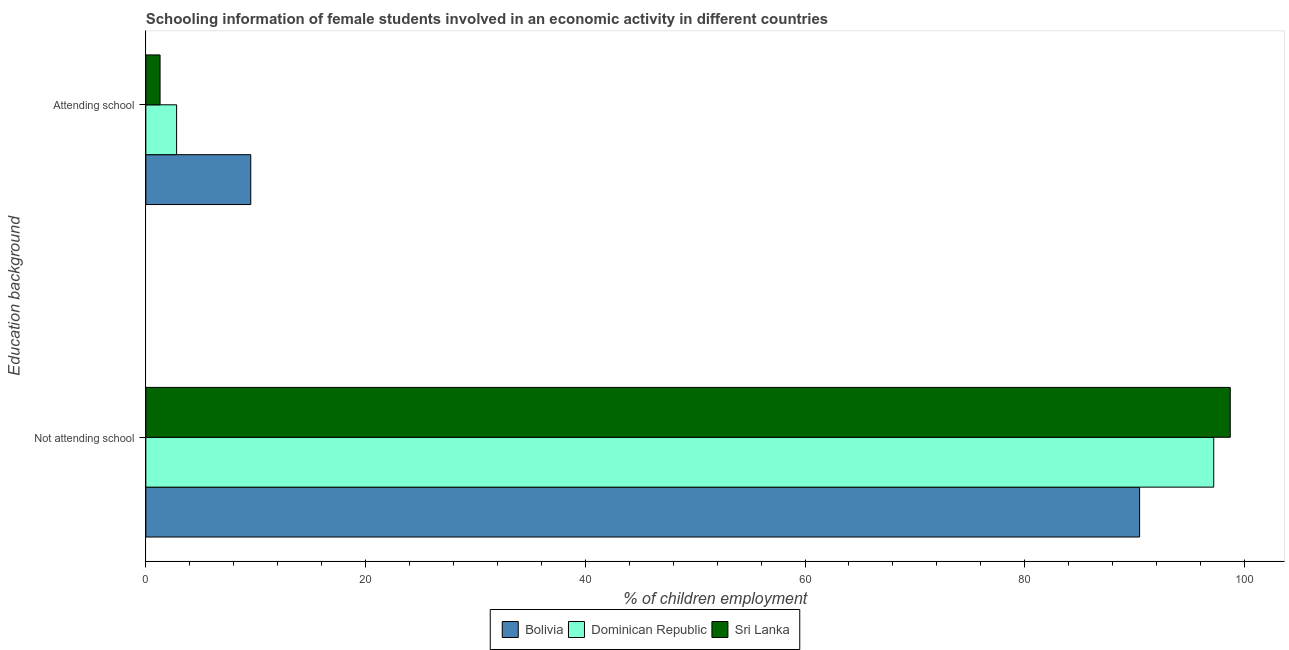Are the number of bars per tick equal to the number of legend labels?
Keep it short and to the point. Yes. Are the number of bars on each tick of the Y-axis equal?
Make the answer very short. Yes. How many bars are there on the 2nd tick from the top?
Provide a short and direct response. 3. What is the label of the 2nd group of bars from the top?
Your answer should be very brief. Not attending school. What is the percentage of employed females who are not attending school in Bolivia?
Offer a very short reply. 90.45. Across all countries, what is the maximum percentage of employed females who are attending school?
Provide a succinct answer. 9.55. Across all countries, what is the minimum percentage of employed females who are not attending school?
Offer a very short reply. 90.45. In which country was the percentage of employed females who are not attending school minimum?
Provide a short and direct response. Bolivia. What is the total percentage of employed females who are attending school in the graph?
Your response must be concise. 13.64. What is the difference between the percentage of employed females who are not attending school in Dominican Republic and that in Bolivia?
Keep it short and to the point. 6.75. What is the difference between the percentage of employed females who are attending school in Dominican Republic and the percentage of employed females who are not attending school in Bolivia?
Your answer should be very brief. -87.65. What is the average percentage of employed females who are attending school per country?
Keep it short and to the point. 4.55. What is the difference between the percentage of employed females who are attending school and percentage of employed females who are not attending school in Sri Lanka?
Make the answer very short. -97.41. What is the ratio of the percentage of employed females who are attending school in Sri Lanka to that in Bolivia?
Offer a very short reply. 0.14. In how many countries, is the percentage of employed females who are not attending school greater than the average percentage of employed females who are not attending school taken over all countries?
Provide a short and direct response. 2. What does the 2nd bar from the top in Not attending school represents?
Provide a short and direct response. Dominican Republic. What does the 2nd bar from the bottom in Not attending school represents?
Your answer should be very brief. Dominican Republic. How many countries are there in the graph?
Make the answer very short. 3. What is the difference between two consecutive major ticks on the X-axis?
Provide a short and direct response. 20. Are the values on the major ticks of X-axis written in scientific E-notation?
Offer a terse response. No. Does the graph contain any zero values?
Offer a very short reply. No. How many legend labels are there?
Offer a terse response. 3. How are the legend labels stacked?
Give a very brief answer. Horizontal. What is the title of the graph?
Offer a very short reply. Schooling information of female students involved in an economic activity in different countries. What is the label or title of the X-axis?
Give a very brief answer. % of children employment. What is the label or title of the Y-axis?
Offer a very short reply. Education background. What is the % of children employment of Bolivia in Not attending school?
Give a very brief answer. 90.45. What is the % of children employment of Dominican Republic in Not attending school?
Ensure brevity in your answer.  97.2. What is the % of children employment in Sri Lanka in Not attending school?
Your answer should be compact. 98.71. What is the % of children employment of Bolivia in Attending school?
Provide a short and direct response. 9.55. What is the % of children employment of Sri Lanka in Attending school?
Provide a succinct answer. 1.29. Across all Education background, what is the maximum % of children employment in Bolivia?
Your answer should be very brief. 90.45. Across all Education background, what is the maximum % of children employment of Dominican Republic?
Your answer should be very brief. 97.2. Across all Education background, what is the maximum % of children employment in Sri Lanka?
Provide a succinct answer. 98.71. Across all Education background, what is the minimum % of children employment in Bolivia?
Your answer should be very brief. 9.55. Across all Education background, what is the minimum % of children employment in Sri Lanka?
Provide a short and direct response. 1.29. What is the total % of children employment of Bolivia in the graph?
Make the answer very short. 100. What is the total % of children employment in Dominican Republic in the graph?
Make the answer very short. 100. What is the total % of children employment in Sri Lanka in the graph?
Offer a terse response. 100. What is the difference between the % of children employment in Bolivia in Not attending school and that in Attending school?
Give a very brief answer. 80.9. What is the difference between the % of children employment in Dominican Republic in Not attending school and that in Attending school?
Make the answer very short. 94.4. What is the difference between the % of children employment in Sri Lanka in Not attending school and that in Attending school?
Offer a very short reply. 97.41. What is the difference between the % of children employment in Bolivia in Not attending school and the % of children employment in Dominican Republic in Attending school?
Provide a succinct answer. 87.65. What is the difference between the % of children employment in Bolivia in Not attending school and the % of children employment in Sri Lanka in Attending school?
Give a very brief answer. 89.16. What is the difference between the % of children employment of Dominican Republic in Not attending school and the % of children employment of Sri Lanka in Attending school?
Offer a terse response. 95.91. What is the average % of children employment in Sri Lanka per Education background?
Offer a very short reply. 50. What is the difference between the % of children employment in Bolivia and % of children employment in Dominican Republic in Not attending school?
Your response must be concise. -6.75. What is the difference between the % of children employment of Bolivia and % of children employment of Sri Lanka in Not attending school?
Offer a terse response. -8.25. What is the difference between the % of children employment of Dominican Republic and % of children employment of Sri Lanka in Not attending school?
Offer a very short reply. -1.5. What is the difference between the % of children employment in Bolivia and % of children employment in Dominican Republic in Attending school?
Your response must be concise. 6.75. What is the difference between the % of children employment in Bolivia and % of children employment in Sri Lanka in Attending school?
Keep it short and to the point. 8.25. What is the difference between the % of children employment of Dominican Republic and % of children employment of Sri Lanka in Attending school?
Your response must be concise. 1.5. What is the ratio of the % of children employment in Bolivia in Not attending school to that in Attending school?
Provide a short and direct response. 9.47. What is the ratio of the % of children employment of Dominican Republic in Not attending school to that in Attending school?
Provide a short and direct response. 34.71. What is the ratio of the % of children employment of Sri Lanka in Not attending school to that in Attending school?
Ensure brevity in your answer.  76.22. What is the difference between the highest and the second highest % of children employment of Bolivia?
Make the answer very short. 80.9. What is the difference between the highest and the second highest % of children employment of Dominican Republic?
Make the answer very short. 94.4. What is the difference between the highest and the second highest % of children employment in Sri Lanka?
Provide a short and direct response. 97.41. What is the difference between the highest and the lowest % of children employment in Bolivia?
Give a very brief answer. 80.9. What is the difference between the highest and the lowest % of children employment of Dominican Republic?
Provide a short and direct response. 94.4. What is the difference between the highest and the lowest % of children employment of Sri Lanka?
Your answer should be very brief. 97.41. 